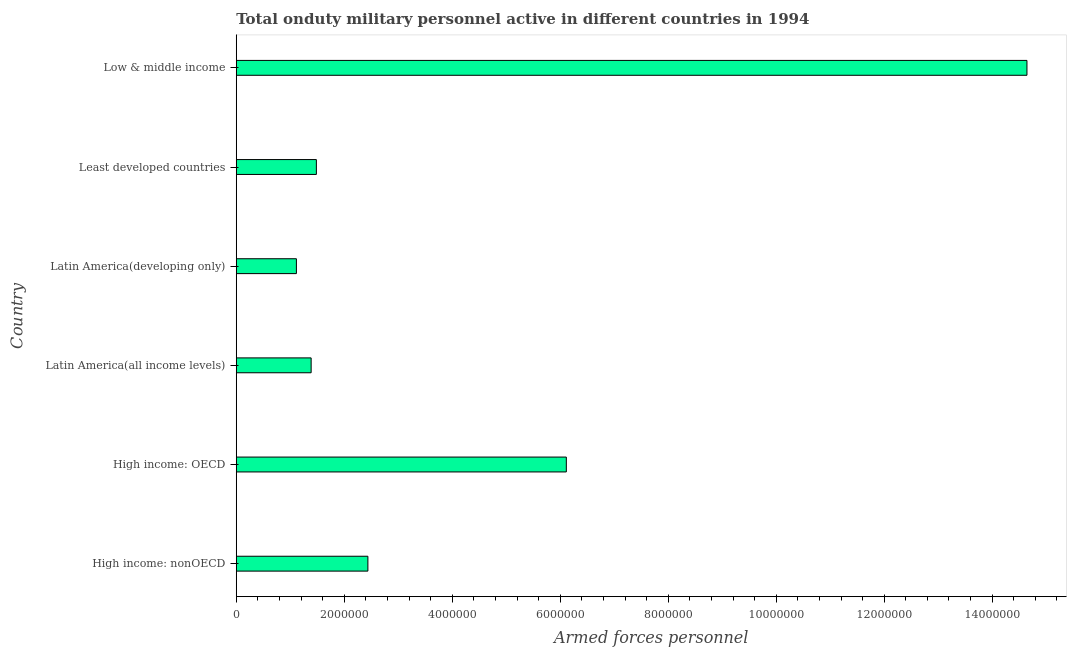Does the graph contain any zero values?
Your answer should be compact. No. Does the graph contain grids?
Offer a very short reply. No. What is the title of the graph?
Offer a very short reply. Total onduty military personnel active in different countries in 1994. What is the label or title of the X-axis?
Give a very brief answer. Armed forces personnel. What is the number of armed forces personnel in High income: nonOECD?
Give a very brief answer. 2.44e+06. Across all countries, what is the maximum number of armed forces personnel?
Your answer should be very brief. 1.46e+07. Across all countries, what is the minimum number of armed forces personnel?
Your answer should be very brief. 1.11e+06. In which country was the number of armed forces personnel minimum?
Offer a very short reply. Latin America(developing only). What is the sum of the number of armed forces personnel?
Keep it short and to the point. 2.72e+07. What is the difference between the number of armed forces personnel in Least developed countries and Low & middle income?
Provide a short and direct response. -1.32e+07. What is the average number of armed forces personnel per country?
Keep it short and to the point. 4.53e+06. What is the median number of armed forces personnel?
Offer a very short reply. 1.96e+06. In how many countries, is the number of armed forces personnel greater than 6400000 ?
Give a very brief answer. 1. What is the ratio of the number of armed forces personnel in Latin America(developing only) to that in Low & middle income?
Provide a succinct answer. 0.08. Is the number of armed forces personnel in High income: nonOECD less than that in Least developed countries?
Offer a very short reply. No. Is the difference between the number of armed forces personnel in Latin America(developing only) and Least developed countries greater than the difference between any two countries?
Ensure brevity in your answer.  No. What is the difference between the highest and the second highest number of armed forces personnel?
Provide a succinct answer. 8.53e+06. Is the sum of the number of armed forces personnel in Latin America(all income levels) and Low & middle income greater than the maximum number of armed forces personnel across all countries?
Offer a terse response. Yes. What is the difference between the highest and the lowest number of armed forces personnel?
Ensure brevity in your answer.  1.35e+07. How many bars are there?
Make the answer very short. 6. How many countries are there in the graph?
Your answer should be very brief. 6. What is the Armed forces personnel of High income: nonOECD?
Your answer should be compact. 2.44e+06. What is the Armed forces personnel in High income: OECD?
Offer a terse response. 6.11e+06. What is the Armed forces personnel of Latin America(all income levels)?
Keep it short and to the point. 1.39e+06. What is the Armed forces personnel of Latin America(developing only)?
Offer a very short reply. 1.11e+06. What is the Armed forces personnel of Least developed countries?
Offer a terse response. 1.48e+06. What is the Armed forces personnel in Low & middle income?
Give a very brief answer. 1.46e+07. What is the difference between the Armed forces personnel in High income: nonOECD and High income: OECD?
Provide a succinct answer. -3.68e+06. What is the difference between the Armed forces personnel in High income: nonOECD and Latin America(all income levels)?
Offer a terse response. 1.05e+06. What is the difference between the Armed forces personnel in High income: nonOECD and Latin America(developing only)?
Offer a very short reply. 1.32e+06. What is the difference between the Armed forces personnel in High income: nonOECD and Least developed countries?
Provide a succinct answer. 9.54e+05. What is the difference between the Armed forces personnel in High income: nonOECD and Low & middle income?
Ensure brevity in your answer.  -1.22e+07. What is the difference between the Armed forces personnel in High income: OECD and Latin America(all income levels)?
Offer a terse response. 4.73e+06. What is the difference between the Armed forces personnel in High income: OECD and Latin America(developing only)?
Offer a very short reply. 5.00e+06. What is the difference between the Armed forces personnel in High income: OECD and Least developed countries?
Ensure brevity in your answer.  4.63e+06. What is the difference between the Armed forces personnel in High income: OECD and Low & middle income?
Keep it short and to the point. -8.53e+06. What is the difference between the Armed forces personnel in Latin America(all income levels) and Latin America(developing only)?
Offer a very short reply. 2.73e+05. What is the difference between the Armed forces personnel in Latin America(all income levels) and Least developed countries?
Your answer should be very brief. -9.70e+04. What is the difference between the Armed forces personnel in Latin America(all income levels) and Low & middle income?
Keep it short and to the point. -1.33e+07. What is the difference between the Armed forces personnel in Latin America(developing only) and Least developed countries?
Provide a short and direct response. -3.70e+05. What is the difference between the Armed forces personnel in Latin America(developing only) and Low & middle income?
Give a very brief answer. -1.35e+07. What is the difference between the Armed forces personnel in Least developed countries and Low & middle income?
Your answer should be compact. -1.32e+07. What is the ratio of the Armed forces personnel in High income: nonOECD to that in High income: OECD?
Give a very brief answer. 0.4. What is the ratio of the Armed forces personnel in High income: nonOECD to that in Latin America(all income levels)?
Provide a short and direct response. 1.76. What is the ratio of the Armed forces personnel in High income: nonOECD to that in Latin America(developing only)?
Offer a terse response. 2.19. What is the ratio of the Armed forces personnel in High income: nonOECD to that in Least developed countries?
Keep it short and to the point. 1.64. What is the ratio of the Armed forces personnel in High income: nonOECD to that in Low & middle income?
Ensure brevity in your answer.  0.17. What is the ratio of the Armed forces personnel in High income: OECD to that in Latin America(all income levels)?
Offer a very short reply. 4.41. What is the ratio of the Armed forces personnel in High income: OECD to that in Latin America(developing only)?
Provide a short and direct response. 5.49. What is the ratio of the Armed forces personnel in High income: OECD to that in Least developed countries?
Keep it short and to the point. 4.12. What is the ratio of the Armed forces personnel in High income: OECD to that in Low & middle income?
Provide a succinct answer. 0.42. What is the ratio of the Armed forces personnel in Latin America(all income levels) to that in Latin America(developing only)?
Provide a short and direct response. 1.25. What is the ratio of the Armed forces personnel in Latin America(all income levels) to that in Least developed countries?
Make the answer very short. 0.94. What is the ratio of the Armed forces personnel in Latin America(all income levels) to that in Low & middle income?
Your response must be concise. 0.1. What is the ratio of the Armed forces personnel in Latin America(developing only) to that in Least developed countries?
Make the answer very short. 0.75. What is the ratio of the Armed forces personnel in Latin America(developing only) to that in Low & middle income?
Offer a very short reply. 0.08. What is the ratio of the Armed forces personnel in Least developed countries to that in Low & middle income?
Provide a short and direct response. 0.1. 